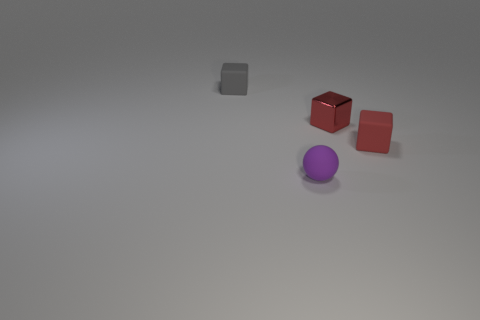Subtract all red blocks. How many blocks are left? 1 Subtract all purple spheres. How many red blocks are left? 2 Add 4 cyan shiny cylinders. How many objects exist? 8 Add 3 small purple things. How many small purple things are left? 4 Add 4 tiny matte cubes. How many tiny matte cubes exist? 6 Subtract 0 cyan blocks. How many objects are left? 4 Subtract all blocks. How many objects are left? 1 Subtract all green cubes. Subtract all red cylinders. How many cubes are left? 3 Subtract all gray things. Subtract all gray shiny things. How many objects are left? 3 